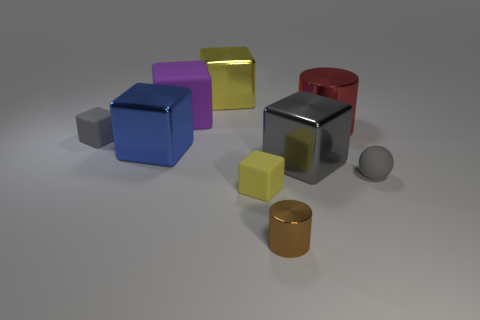Does the tiny brown thing have the same material as the large yellow object?
Your answer should be compact. Yes. What number of blocks are either big purple matte things or large yellow shiny things?
Your response must be concise. 2. How big is the shiny cylinder in front of the small rubber block behind the small gray thing that is to the right of the big yellow object?
Give a very brief answer. Small. The gray matte object that is the same shape as the blue thing is what size?
Offer a terse response. Small. What number of metallic objects are behind the big purple block?
Keep it short and to the point. 1. Do the metal cube that is right of the brown cylinder and the tiny ball have the same color?
Make the answer very short. Yes. What number of purple objects are blocks or metallic cylinders?
Offer a terse response. 1. There is a metal thing that is in front of the gray ball that is in front of the red shiny cylinder; what color is it?
Give a very brief answer. Brown. What material is the large thing that is the same color as the ball?
Make the answer very short. Metal. What is the color of the large metal object left of the large purple thing?
Ensure brevity in your answer.  Blue. 